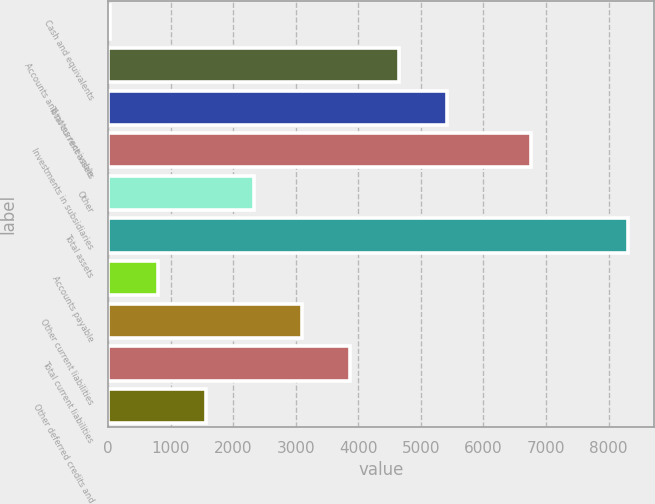Convert chart to OTSL. <chart><loc_0><loc_0><loc_500><loc_500><bar_chart><fcel>Cash and equivalents<fcel>Accounts and notes receivable<fcel>Total current assets<fcel>Investments in subsidiaries<fcel>Other<fcel>Total assets<fcel>Accounts payable<fcel>Other current liabilities<fcel>Total current liabilities<fcel>Other deferred credits and<nl><fcel>22<fcel>4642.6<fcel>5412.7<fcel>6764<fcel>2332.3<fcel>8304.2<fcel>792.1<fcel>3102.4<fcel>3872.5<fcel>1562.2<nl></chart> 